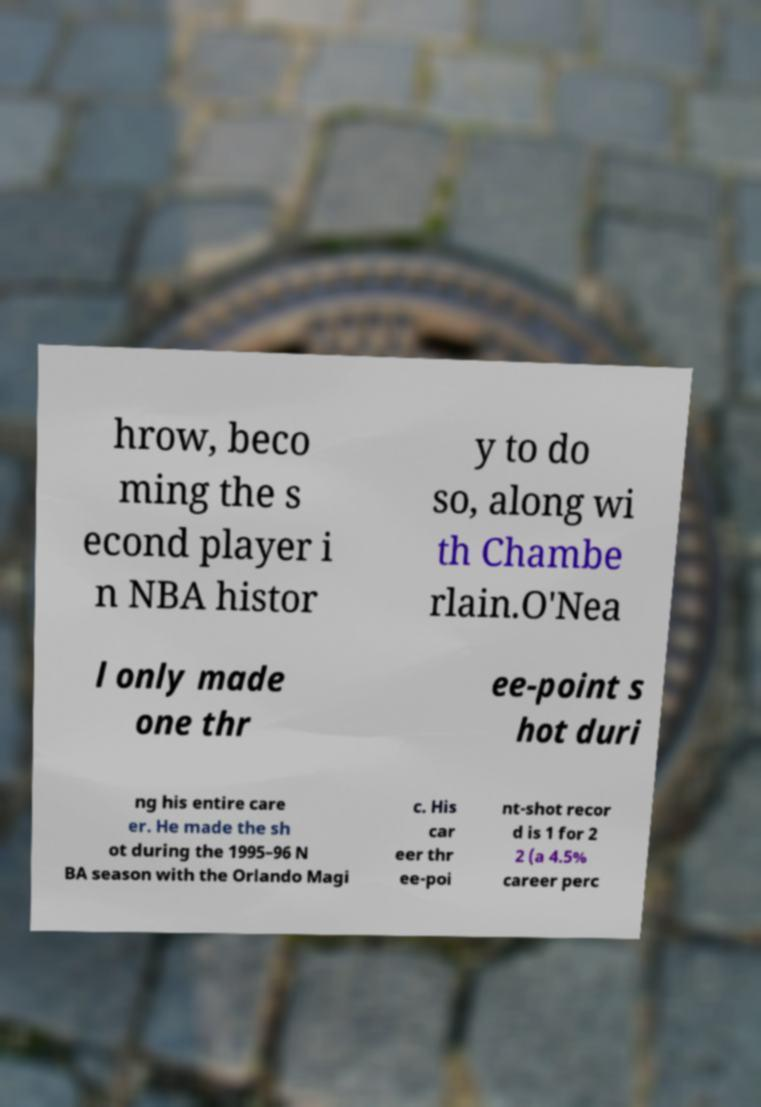Could you assist in decoding the text presented in this image and type it out clearly? hrow, beco ming the s econd player i n NBA histor y to do so, along wi th Chambe rlain.O'Nea l only made one thr ee-point s hot duri ng his entire care er. He made the sh ot during the 1995–96 N BA season with the Orlando Magi c. His car eer thr ee-poi nt-shot recor d is 1 for 2 2 (a 4.5% career perc 